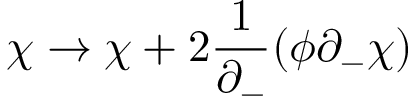<formula> <loc_0><loc_0><loc_500><loc_500>\chi \rightarrow \chi + 2 \frac { 1 } { \partial _ { - } } ( \phi \partial _ { - } \chi )</formula> 